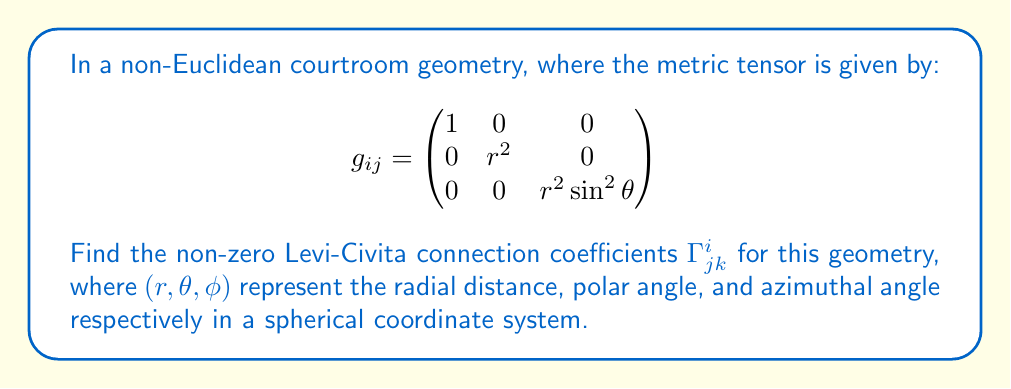Show me your answer to this math problem. To find the Levi-Civita connection coefficients, we'll follow these steps:

1) The Levi-Civita connection coefficients are given by:

   $$\Gamma^i_{jk} = \frac{1}{2}g^{im}(\partial_j g_{km} + \partial_k g_{jm} - \partial_m g_{jk})$$

2) First, we need to calculate the inverse metric tensor $g^{ij}$:

   $$g^{ij} = \begin{pmatrix}
   1 & 0 & 0 \\
   0 & \frac{1}{r^2} & 0 \\
   0 & 0 & \frac{1}{r^2\sin^2\theta}
   \end{pmatrix}$$

3) Now, we calculate the partial derivatives of the metric tensor components:

   $\partial_r g_{rr} = 0$
   $\partial_r g_{\theta\theta} = 2r$
   $\partial_r g_{\phi\phi} = 2r\sin^2\theta$
   $\partial_\theta g_{\phi\phi} = 2r^2\sin\theta\cos\theta$

4) Using the formula, we can calculate the non-zero coefficients:

   $\Gamma^r_{\theta\theta} = -r$
   $\Gamma^r_{\phi\phi} = -r\sin^2\theta$
   $\Gamma^\theta_{r\theta} = \Gamma^\theta_{\theta r} = \frac{1}{r}$
   $\Gamma^\theta_{\phi\phi} = -\sin\theta\cos\theta$
   $\Gamma^\phi_{r\phi} = \Gamma^\phi_{\phi r} = \frac{1}{r}$
   $\Gamma^\phi_{\theta\phi} = \Gamma^\phi_{\phi\theta} = \cot\theta$

5) All other coefficients are zero due to the symmetry of the metric tensor and the properties of partial derivatives.
Answer: $\Gamma^r_{\theta\theta} = -r$, $\Gamma^r_{\phi\phi} = -r\sin^2\theta$, $\Gamma^\theta_{r\theta} = \Gamma^\theta_{\theta r} = \frac{1}{r}$, $\Gamma^\theta_{\phi\phi} = -\sin\theta\cos\theta$, $\Gamma^\phi_{r\phi} = \Gamma^\phi_{\phi r} = \frac{1}{r}$, $\Gamma^\phi_{\theta\phi} = \Gamma^\phi_{\phi\theta} = \cot\theta$ 